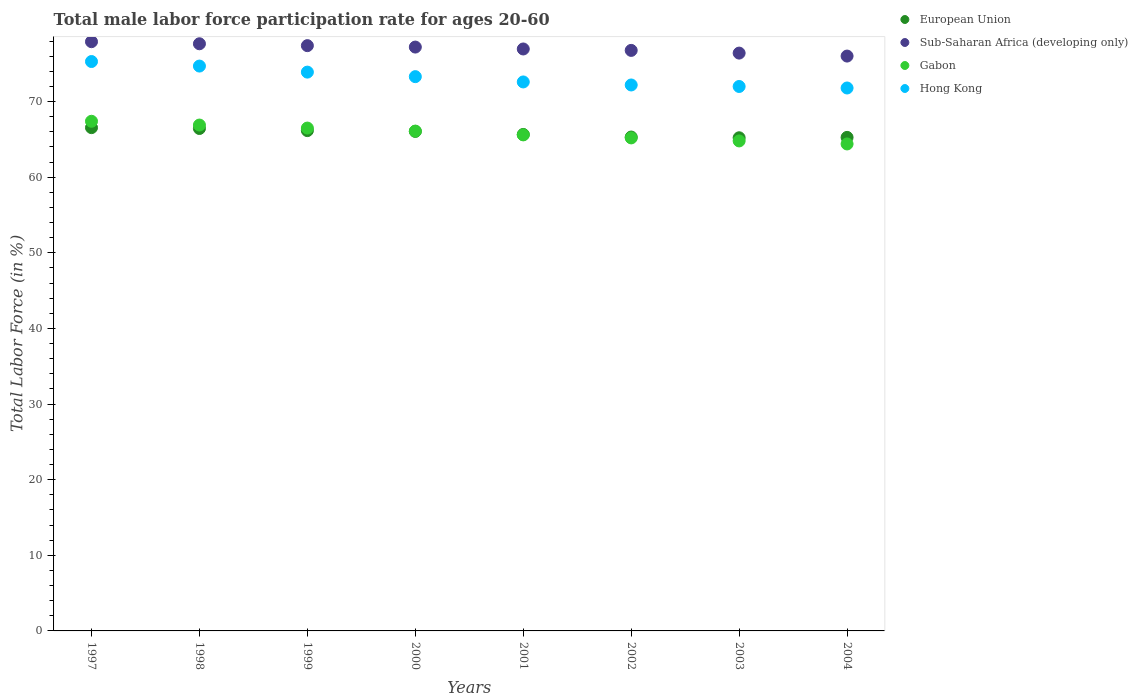How many different coloured dotlines are there?
Make the answer very short. 4. Is the number of dotlines equal to the number of legend labels?
Your answer should be compact. Yes. What is the male labor force participation rate in Gabon in 1998?
Your response must be concise. 66.9. Across all years, what is the maximum male labor force participation rate in Sub-Saharan Africa (developing only)?
Give a very brief answer. 77.92. Across all years, what is the minimum male labor force participation rate in European Union?
Offer a terse response. 65.22. In which year was the male labor force participation rate in European Union maximum?
Ensure brevity in your answer.  1997. What is the total male labor force participation rate in Hong Kong in the graph?
Your answer should be very brief. 585.8. What is the difference between the male labor force participation rate in European Union in 1997 and that in 2001?
Your answer should be compact. 0.9. What is the difference between the male labor force participation rate in European Union in 2001 and the male labor force participation rate in Gabon in 2000?
Offer a very short reply. -0.44. What is the average male labor force participation rate in European Union per year?
Offer a very short reply. 65.84. In the year 1999, what is the difference between the male labor force participation rate in Gabon and male labor force participation rate in European Union?
Keep it short and to the point. 0.34. In how many years, is the male labor force participation rate in Gabon greater than 60 %?
Give a very brief answer. 8. What is the ratio of the male labor force participation rate in European Union in 1998 to that in 1999?
Offer a very short reply. 1. Is the male labor force participation rate in Hong Kong in 2000 less than that in 2001?
Make the answer very short. No. Is the difference between the male labor force participation rate in Gabon in 1997 and 2003 greater than the difference between the male labor force participation rate in European Union in 1997 and 2003?
Give a very brief answer. Yes. What is the difference between the highest and the second highest male labor force participation rate in Sub-Saharan Africa (developing only)?
Ensure brevity in your answer.  0.28. In how many years, is the male labor force participation rate in Gabon greater than the average male labor force participation rate in Gabon taken over all years?
Offer a very short reply. 4. Is it the case that in every year, the sum of the male labor force participation rate in Sub-Saharan Africa (developing only) and male labor force participation rate in Hong Kong  is greater than the male labor force participation rate in Gabon?
Offer a very short reply. Yes. Is the male labor force participation rate in Gabon strictly less than the male labor force participation rate in Hong Kong over the years?
Make the answer very short. Yes. How many dotlines are there?
Your response must be concise. 4. Does the graph contain any zero values?
Provide a short and direct response. No. Where does the legend appear in the graph?
Ensure brevity in your answer.  Top right. What is the title of the graph?
Your answer should be compact. Total male labor force participation rate for ages 20-60. What is the label or title of the X-axis?
Your answer should be very brief. Years. What is the label or title of the Y-axis?
Your answer should be compact. Total Labor Force (in %). What is the Total Labor Force (in %) of European Union in 1997?
Provide a short and direct response. 66.56. What is the Total Labor Force (in %) in Sub-Saharan Africa (developing only) in 1997?
Your response must be concise. 77.92. What is the Total Labor Force (in %) of Gabon in 1997?
Ensure brevity in your answer.  67.4. What is the Total Labor Force (in %) in Hong Kong in 1997?
Keep it short and to the point. 75.3. What is the Total Labor Force (in %) of European Union in 1998?
Your response must be concise. 66.44. What is the Total Labor Force (in %) in Sub-Saharan Africa (developing only) in 1998?
Offer a terse response. 77.65. What is the Total Labor Force (in %) in Gabon in 1998?
Offer a very short reply. 66.9. What is the Total Labor Force (in %) of Hong Kong in 1998?
Make the answer very short. 74.7. What is the Total Labor Force (in %) of European Union in 1999?
Your answer should be compact. 66.16. What is the Total Labor Force (in %) in Sub-Saharan Africa (developing only) in 1999?
Your answer should be compact. 77.4. What is the Total Labor Force (in %) of Gabon in 1999?
Provide a short and direct response. 66.5. What is the Total Labor Force (in %) in Hong Kong in 1999?
Your response must be concise. 73.9. What is the Total Labor Force (in %) of European Union in 2000?
Your answer should be compact. 66.06. What is the Total Labor Force (in %) in Sub-Saharan Africa (developing only) in 2000?
Your answer should be compact. 77.21. What is the Total Labor Force (in %) of Gabon in 2000?
Provide a short and direct response. 66.1. What is the Total Labor Force (in %) in Hong Kong in 2000?
Provide a short and direct response. 73.3. What is the Total Labor Force (in %) of European Union in 2001?
Make the answer very short. 65.66. What is the Total Labor Force (in %) in Sub-Saharan Africa (developing only) in 2001?
Your answer should be compact. 76.96. What is the Total Labor Force (in %) in Gabon in 2001?
Provide a short and direct response. 65.6. What is the Total Labor Force (in %) in Hong Kong in 2001?
Provide a short and direct response. 72.6. What is the Total Labor Force (in %) in European Union in 2002?
Ensure brevity in your answer.  65.31. What is the Total Labor Force (in %) of Sub-Saharan Africa (developing only) in 2002?
Provide a short and direct response. 76.77. What is the Total Labor Force (in %) of Gabon in 2002?
Keep it short and to the point. 65.2. What is the Total Labor Force (in %) of Hong Kong in 2002?
Your answer should be very brief. 72.2. What is the Total Labor Force (in %) of European Union in 2003?
Your response must be concise. 65.22. What is the Total Labor Force (in %) in Sub-Saharan Africa (developing only) in 2003?
Offer a terse response. 76.42. What is the Total Labor Force (in %) of Gabon in 2003?
Keep it short and to the point. 64.8. What is the Total Labor Force (in %) of Hong Kong in 2003?
Your answer should be compact. 72. What is the Total Labor Force (in %) of European Union in 2004?
Your answer should be very brief. 65.27. What is the Total Labor Force (in %) of Sub-Saharan Africa (developing only) in 2004?
Provide a short and direct response. 76.02. What is the Total Labor Force (in %) in Gabon in 2004?
Your answer should be very brief. 64.4. What is the Total Labor Force (in %) of Hong Kong in 2004?
Your answer should be compact. 71.8. Across all years, what is the maximum Total Labor Force (in %) in European Union?
Offer a very short reply. 66.56. Across all years, what is the maximum Total Labor Force (in %) in Sub-Saharan Africa (developing only)?
Your answer should be very brief. 77.92. Across all years, what is the maximum Total Labor Force (in %) in Gabon?
Provide a succinct answer. 67.4. Across all years, what is the maximum Total Labor Force (in %) in Hong Kong?
Your answer should be compact. 75.3. Across all years, what is the minimum Total Labor Force (in %) in European Union?
Provide a short and direct response. 65.22. Across all years, what is the minimum Total Labor Force (in %) in Sub-Saharan Africa (developing only)?
Your response must be concise. 76.02. Across all years, what is the minimum Total Labor Force (in %) of Gabon?
Make the answer very short. 64.4. Across all years, what is the minimum Total Labor Force (in %) of Hong Kong?
Provide a short and direct response. 71.8. What is the total Total Labor Force (in %) of European Union in the graph?
Provide a succinct answer. 526.68. What is the total Total Labor Force (in %) in Sub-Saharan Africa (developing only) in the graph?
Provide a short and direct response. 616.36. What is the total Total Labor Force (in %) of Gabon in the graph?
Your answer should be very brief. 526.9. What is the total Total Labor Force (in %) of Hong Kong in the graph?
Your answer should be compact. 585.8. What is the difference between the Total Labor Force (in %) of European Union in 1997 and that in 1998?
Give a very brief answer. 0.11. What is the difference between the Total Labor Force (in %) in Sub-Saharan Africa (developing only) in 1997 and that in 1998?
Your answer should be very brief. 0.28. What is the difference between the Total Labor Force (in %) in Gabon in 1997 and that in 1998?
Ensure brevity in your answer.  0.5. What is the difference between the Total Labor Force (in %) of Hong Kong in 1997 and that in 1998?
Make the answer very short. 0.6. What is the difference between the Total Labor Force (in %) of European Union in 1997 and that in 1999?
Make the answer very short. 0.39. What is the difference between the Total Labor Force (in %) in Sub-Saharan Africa (developing only) in 1997 and that in 1999?
Provide a short and direct response. 0.52. What is the difference between the Total Labor Force (in %) in European Union in 1997 and that in 2000?
Make the answer very short. 0.5. What is the difference between the Total Labor Force (in %) of Sub-Saharan Africa (developing only) in 1997 and that in 2000?
Provide a short and direct response. 0.71. What is the difference between the Total Labor Force (in %) of European Union in 1997 and that in 2001?
Provide a succinct answer. 0.9. What is the difference between the Total Labor Force (in %) in Sub-Saharan Africa (developing only) in 1997 and that in 2001?
Provide a short and direct response. 0.96. What is the difference between the Total Labor Force (in %) in Gabon in 1997 and that in 2001?
Offer a very short reply. 1.8. What is the difference between the Total Labor Force (in %) in Hong Kong in 1997 and that in 2001?
Make the answer very short. 2.7. What is the difference between the Total Labor Force (in %) in European Union in 1997 and that in 2002?
Ensure brevity in your answer.  1.24. What is the difference between the Total Labor Force (in %) of Sub-Saharan Africa (developing only) in 1997 and that in 2002?
Your response must be concise. 1.15. What is the difference between the Total Labor Force (in %) of Gabon in 1997 and that in 2002?
Offer a very short reply. 2.2. What is the difference between the Total Labor Force (in %) of Hong Kong in 1997 and that in 2002?
Make the answer very short. 3.1. What is the difference between the Total Labor Force (in %) in European Union in 1997 and that in 2003?
Provide a succinct answer. 1.34. What is the difference between the Total Labor Force (in %) in Sub-Saharan Africa (developing only) in 1997 and that in 2003?
Give a very brief answer. 1.51. What is the difference between the Total Labor Force (in %) in Hong Kong in 1997 and that in 2003?
Offer a very short reply. 3.3. What is the difference between the Total Labor Force (in %) of European Union in 1997 and that in 2004?
Your response must be concise. 1.29. What is the difference between the Total Labor Force (in %) in Sub-Saharan Africa (developing only) in 1997 and that in 2004?
Your answer should be very brief. 1.9. What is the difference between the Total Labor Force (in %) of European Union in 1998 and that in 1999?
Your answer should be compact. 0.28. What is the difference between the Total Labor Force (in %) of Sub-Saharan Africa (developing only) in 1998 and that in 1999?
Keep it short and to the point. 0.25. What is the difference between the Total Labor Force (in %) in European Union in 1998 and that in 2000?
Your answer should be compact. 0.38. What is the difference between the Total Labor Force (in %) of Sub-Saharan Africa (developing only) in 1998 and that in 2000?
Offer a very short reply. 0.44. What is the difference between the Total Labor Force (in %) in Gabon in 1998 and that in 2000?
Your response must be concise. 0.8. What is the difference between the Total Labor Force (in %) in Hong Kong in 1998 and that in 2000?
Ensure brevity in your answer.  1.4. What is the difference between the Total Labor Force (in %) of European Union in 1998 and that in 2001?
Ensure brevity in your answer.  0.79. What is the difference between the Total Labor Force (in %) in Sub-Saharan Africa (developing only) in 1998 and that in 2001?
Your answer should be compact. 0.69. What is the difference between the Total Labor Force (in %) of Gabon in 1998 and that in 2001?
Provide a short and direct response. 1.3. What is the difference between the Total Labor Force (in %) in European Union in 1998 and that in 2002?
Your response must be concise. 1.13. What is the difference between the Total Labor Force (in %) in Sub-Saharan Africa (developing only) in 1998 and that in 2002?
Offer a very short reply. 0.88. What is the difference between the Total Labor Force (in %) in Gabon in 1998 and that in 2002?
Your answer should be compact. 1.7. What is the difference between the Total Labor Force (in %) of Hong Kong in 1998 and that in 2002?
Offer a terse response. 2.5. What is the difference between the Total Labor Force (in %) of European Union in 1998 and that in 2003?
Offer a very short reply. 1.23. What is the difference between the Total Labor Force (in %) in Sub-Saharan Africa (developing only) in 1998 and that in 2003?
Your answer should be compact. 1.23. What is the difference between the Total Labor Force (in %) of Gabon in 1998 and that in 2003?
Your answer should be compact. 2.1. What is the difference between the Total Labor Force (in %) of Hong Kong in 1998 and that in 2003?
Keep it short and to the point. 2.7. What is the difference between the Total Labor Force (in %) of European Union in 1998 and that in 2004?
Your response must be concise. 1.18. What is the difference between the Total Labor Force (in %) of Sub-Saharan Africa (developing only) in 1998 and that in 2004?
Your response must be concise. 1.63. What is the difference between the Total Labor Force (in %) of Gabon in 1998 and that in 2004?
Your answer should be compact. 2.5. What is the difference between the Total Labor Force (in %) of Hong Kong in 1998 and that in 2004?
Keep it short and to the point. 2.9. What is the difference between the Total Labor Force (in %) of European Union in 1999 and that in 2000?
Offer a very short reply. 0.1. What is the difference between the Total Labor Force (in %) of Sub-Saharan Africa (developing only) in 1999 and that in 2000?
Make the answer very short. 0.19. What is the difference between the Total Labor Force (in %) of Gabon in 1999 and that in 2000?
Your response must be concise. 0.4. What is the difference between the Total Labor Force (in %) in European Union in 1999 and that in 2001?
Give a very brief answer. 0.51. What is the difference between the Total Labor Force (in %) in Sub-Saharan Africa (developing only) in 1999 and that in 2001?
Give a very brief answer. 0.44. What is the difference between the Total Labor Force (in %) in European Union in 1999 and that in 2002?
Make the answer very short. 0.85. What is the difference between the Total Labor Force (in %) in Sub-Saharan Africa (developing only) in 1999 and that in 2002?
Give a very brief answer. 0.63. What is the difference between the Total Labor Force (in %) in Gabon in 1999 and that in 2002?
Your answer should be compact. 1.3. What is the difference between the Total Labor Force (in %) of Hong Kong in 1999 and that in 2002?
Provide a short and direct response. 1.7. What is the difference between the Total Labor Force (in %) of European Union in 1999 and that in 2003?
Ensure brevity in your answer.  0.95. What is the difference between the Total Labor Force (in %) of Gabon in 1999 and that in 2003?
Offer a terse response. 1.7. What is the difference between the Total Labor Force (in %) in European Union in 1999 and that in 2004?
Offer a terse response. 0.9. What is the difference between the Total Labor Force (in %) in Sub-Saharan Africa (developing only) in 1999 and that in 2004?
Your answer should be compact. 1.38. What is the difference between the Total Labor Force (in %) of Hong Kong in 1999 and that in 2004?
Your response must be concise. 2.1. What is the difference between the Total Labor Force (in %) in European Union in 2000 and that in 2001?
Your response must be concise. 0.41. What is the difference between the Total Labor Force (in %) in Sub-Saharan Africa (developing only) in 2000 and that in 2001?
Your response must be concise. 0.25. What is the difference between the Total Labor Force (in %) of Gabon in 2000 and that in 2001?
Provide a succinct answer. 0.5. What is the difference between the Total Labor Force (in %) of Hong Kong in 2000 and that in 2001?
Ensure brevity in your answer.  0.7. What is the difference between the Total Labor Force (in %) of European Union in 2000 and that in 2002?
Your answer should be very brief. 0.75. What is the difference between the Total Labor Force (in %) in Sub-Saharan Africa (developing only) in 2000 and that in 2002?
Offer a terse response. 0.44. What is the difference between the Total Labor Force (in %) in Gabon in 2000 and that in 2002?
Your answer should be very brief. 0.9. What is the difference between the Total Labor Force (in %) of European Union in 2000 and that in 2003?
Make the answer very short. 0.84. What is the difference between the Total Labor Force (in %) of Sub-Saharan Africa (developing only) in 2000 and that in 2003?
Provide a short and direct response. 0.8. What is the difference between the Total Labor Force (in %) in Hong Kong in 2000 and that in 2003?
Keep it short and to the point. 1.3. What is the difference between the Total Labor Force (in %) in European Union in 2000 and that in 2004?
Ensure brevity in your answer.  0.79. What is the difference between the Total Labor Force (in %) of Sub-Saharan Africa (developing only) in 2000 and that in 2004?
Ensure brevity in your answer.  1.19. What is the difference between the Total Labor Force (in %) in Gabon in 2000 and that in 2004?
Your answer should be very brief. 1.7. What is the difference between the Total Labor Force (in %) of Hong Kong in 2000 and that in 2004?
Make the answer very short. 1.5. What is the difference between the Total Labor Force (in %) in European Union in 2001 and that in 2002?
Provide a succinct answer. 0.34. What is the difference between the Total Labor Force (in %) of Sub-Saharan Africa (developing only) in 2001 and that in 2002?
Ensure brevity in your answer.  0.19. What is the difference between the Total Labor Force (in %) of Gabon in 2001 and that in 2002?
Make the answer very short. 0.4. What is the difference between the Total Labor Force (in %) of Hong Kong in 2001 and that in 2002?
Provide a short and direct response. 0.4. What is the difference between the Total Labor Force (in %) of European Union in 2001 and that in 2003?
Your answer should be compact. 0.44. What is the difference between the Total Labor Force (in %) in Sub-Saharan Africa (developing only) in 2001 and that in 2003?
Ensure brevity in your answer.  0.54. What is the difference between the Total Labor Force (in %) of Gabon in 2001 and that in 2003?
Offer a terse response. 0.8. What is the difference between the Total Labor Force (in %) of Hong Kong in 2001 and that in 2003?
Provide a succinct answer. 0.6. What is the difference between the Total Labor Force (in %) of European Union in 2001 and that in 2004?
Your answer should be very brief. 0.39. What is the difference between the Total Labor Force (in %) of Gabon in 2001 and that in 2004?
Provide a succinct answer. 1.2. What is the difference between the Total Labor Force (in %) in Hong Kong in 2001 and that in 2004?
Make the answer very short. 0.8. What is the difference between the Total Labor Force (in %) in European Union in 2002 and that in 2003?
Your response must be concise. 0.1. What is the difference between the Total Labor Force (in %) in Sub-Saharan Africa (developing only) in 2002 and that in 2003?
Keep it short and to the point. 0.36. What is the difference between the Total Labor Force (in %) in Hong Kong in 2002 and that in 2003?
Your answer should be compact. 0.2. What is the difference between the Total Labor Force (in %) of European Union in 2002 and that in 2004?
Provide a succinct answer. 0.05. What is the difference between the Total Labor Force (in %) in Sub-Saharan Africa (developing only) in 2002 and that in 2004?
Make the answer very short. 0.75. What is the difference between the Total Labor Force (in %) in Gabon in 2002 and that in 2004?
Provide a succinct answer. 0.8. What is the difference between the Total Labor Force (in %) of Hong Kong in 2002 and that in 2004?
Offer a very short reply. 0.4. What is the difference between the Total Labor Force (in %) of European Union in 2003 and that in 2004?
Your answer should be compact. -0.05. What is the difference between the Total Labor Force (in %) of Sub-Saharan Africa (developing only) in 2003 and that in 2004?
Give a very brief answer. 0.39. What is the difference between the Total Labor Force (in %) of Gabon in 2003 and that in 2004?
Your answer should be compact. 0.4. What is the difference between the Total Labor Force (in %) in European Union in 1997 and the Total Labor Force (in %) in Sub-Saharan Africa (developing only) in 1998?
Make the answer very short. -11.09. What is the difference between the Total Labor Force (in %) of European Union in 1997 and the Total Labor Force (in %) of Gabon in 1998?
Ensure brevity in your answer.  -0.34. What is the difference between the Total Labor Force (in %) of European Union in 1997 and the Total Labor Force (in %) of Hong Kong in 1998?
Offer a very short reply. -8.14. What is the difference between the Total Labor Force (in %) in Sub-Saharan Africa (developing only) in 1997 and the Total Labor Force (in %) in Gabon in 1998?
Your answer should be very brief. 11.02. What is the difference between the Total Labor Force (in %) in Sub-Saharan Africa (developing only) in 1997 and the Total Labor Force (in %) in Hong Kong in 1998?
Offer a terse response. 3.22. What is the difference between the Total Labor Force (in %) of European Union in 1997 and the Total Labor Force (in %) of Sub-Saharan Africa (developing only) in 1999?
Your answer should be very brief. -10.84. What is the difference between the Total Labor Force (in %) in European Union in 1997 and the Total Labor Force (in %) in Gabon in 1999?
Provide a short and direct response. 0.06. What is the difference between the Total Labor Force (in %) in European Union in 1997 and the Total Labor Force (in %) in Hong Kong in 1999?
Give a very brief answer. -7.34. What is the difference between the Total Labor Force (in %) of Sub-Saharan Africa (developing only) in 1997 and the Total Labor Force (in %) of Gabon in 1999?
Ensure brevity in your answer.  11.42. What is the difference between the Total Labor Force (in %) of Sub-Saharan Africa (developing only) in 1997 and the Total Labor Force (in %) of Hong Kong in 1999?
Provide a short and direct response. 4.02. What is the difference between the Total Labor Force (in %) in European Union in 1997 and the Total Labor Force (in %) in Sub-Saharan Africa (developing only) in 2000?
Provide a short and direct response. -10.65. What is the difference between the Total Labor Force (in %) of European Union in 1997 and the Total Labor Force (in %) of Gabon in 2000?
Your answer should be compact. 0.46. What is the difference between the Total Labor Force (in %) of European Union in 1997 and the Total Labor Force (in %) of Hong Kong in 2000?
Make the answer very short. -6.74. What is the difference between the Total Labor Force (in %) in Sub-Saharan Africa (developing only) in 1997 and the Total Labor Force (in %) in Gabon in 2000?
Your answer should be very brief. 11.82. What is the difference between the Total Labor Force (in %) in Sub-Saharan Africa (developing only) in 1997 and the Total Labor Force (in %) in Hong Kong in 2000?
Provide a short and direct response. 4.62. What is the difference between the Total Labor Force (in %) in European Union in 1997 and the Total Labor Force (in %) in Sub-Saharan Africa (developing only) in 2001?
Your answer should be very brief. -10.4. What is the difference between the Total Labor Force (in %) in European Union in 1997 and the Total Labor Force (in %) in Gabon in 2001?
Keep it short and to the point. 0.96. What is the difference between the Total Labor Force (in %) in European Union in 1997 and the Total Labor Force (in %) in Hong Kong in 2001?
Your answer should be compact. -6.04. What is the difference between the Total Labor Force (in %) of Sub-Saharan Africa (developing only) in 1997 and the Total Labor Force (in %) of Gabon in 2001?
Offer a terse response. 12.32. What is the difference between the Total Labor Force (in %) in Sub-Saharan Africa (developing only) in 1997 and the Total Labor Force (in %) in Hong Kong in 2001?
Provide a succinct answer. 5.32. What is the difference between the Total Labor Force (in %) of Gabon in 1997 and the Total Labor Force (in %) of Hong Kong in 2001?
Keep it short and to the point. -5.2. What is the difference between the Total Labor Force (in %) in European Union in 1997 and the Total Labor Force (in %) in Sub-Saharan Africa (developing only) in 2002?
Offer a very short reply. -10.21. What is the difference between the Total Labor Force (in %) of European Union in 1997 and the Total Labor Force (in %) of Gabon in 2002?
Provide a short and direct response. 1.36. What is the difference between the Total Labor Force (in %) in European Union in 1997 and the Total Labor Force (in %) in Hong Kong in 2002?
Your answer should be very brief. -5.64. What is the difference between the Total Labor Force (in %) of Sub-Saharan Africa (developing only) in 1997 and the Total Labor Force (in %) of Gabon in 2002?
Provide a succinct answer. 12.72. What is the difference between the Total Labor Force (in %) in Sub-Saharan Africa (developing only) in 1997 and the Total Labor Force (in %) in Hong Kong in 2002?
Make the answer very short. 5.72. What is the difference between the Total Labor Force (in %) in European Union in 1997 and the Total Labor Force (in %) in Sub-Saharan Africa (developing only) in 2003?
Your answer should be compact. -9.86. What is the difference between the Total Labor Force (in %) in European Union in 1997 and the Total Labor Force (in %) in Gabon in 2003?
Give a very brief answer. 1.76. What is the difference between the Total Labor Force (in %) of European Union in 1997 and the Total Labor Force (in %) of Hong Kong in 2003?
Your response must be concise. -5.44. What is the difference between the Total Labor Force (in %) in Sub-Saharan Africa (developing only) in 1997 and the Total Labor Force (in %) in Gabon in 2003?
Ensure brevity in your answer.  13.12. What is the difference between the Total Labor Force (in %) of Sub-Saharan Africa (developing only) in 1997 and the Total Labor Force (in %) of Hong Kong in 2003?
Keep it short and to the point. 5.92. What is the difference between the Total Labor Force (in %) of European Union in 1997 and the Total Labor Force (in %) of Sub-Saharan Africa (developing only) in 2004?
Offer a terse response. -9.46. What is the difference between the Total Labor Force (in %) in European Union in 1997 and the Total Labor Force (in %) in Gabon in 2004?
Make the answer very short. 2.16. What is the difference between the Total Labor Force (in %) of European Union in 1997 and the Total Labor Force (in %) of Hong Kong in 2004?
Your answer should be very brief. -5.24. What is the difference between the Total Labor Force (in %) in Sub-Saharan Africa (developing only) in 1997 and the Total Labor Force (in %) in Gabon in 2004?
Offer a very short reply. 13.52. What is the difference between the Total Labor Force (in %) in Sub-Saharan Africa (developing only) in 1997 and the Total Labor Force (in %) in Hong Kong in 2004?
Ensure brevity in your answer.  6.12. What is the difference between the Total Labor Force (in %) in Gabon in 1997 and the Total Labor Force (in %) in Hong Kong in 2004?
Your response must be concise. -4.4. What is the difference between the Total Labor Force (in %) of European Union in 1998 and the Total Labor Force (in %) of Sub-Saharan Africa (developing only) in 1999?
Provide a succinct answer. -10.96. What is the difference between the Total Labor Force (in %) of European Union in 1998 and the Total Labor Force (in %) of Gabon in 1999?
Keep it short and to the point. -0.06. What is the difference between the Total Labor Force (in %) in European Union in 1998 and the Total Labor Force (in %) in Hong Kong in 1999?
Ensure brevity in your answer.  -7.46. What is the difference between the Total Labor Force (in %) in Sub-Saharan Africa (developing only) in 1998 and the Total Labor Force (in %) in Gabon in 1999?
Keep it short and to the point. 11.15. What is the difference between the Total Labor Force (in %) in Sub-Saharan Africa (developing only) in 1998 and the Total Labor Force (in %) in Hong Kong in 1999?
Offer a very short reply. 3.75. What is the difference between the Total Labor Force (in %) in Gabon in 1998 and the Total Labor Force (in %) in Hong Kong in 1999?
Your answer should be compact. -7. What is the difference between the Total Labor Force (in %) in European Union in 1998 and the Total Labor Force (in %) in Sub-Saharan Africa (developing only) in 2000?
Provide a short and direct response. -10.77. What is the difference between the Total Labor Force (in %) of European Union in 1998 and the Total Labor Force (in %) of Gabon in 2000?
Your answer should be very brief. 0.34. What is the difference between the Total Labor Force (in %) in European Union in 1998 and the Total Labor Force (in %) in Hong Kong in 2000?
Provide a short and direct response. -6.86. What is the difference between the Total Labor Force (in %) in Sub-Saharan Africa (developing only) in 1998 and the Total Labor Force (in %) in Gabon in 2000?
Offer a very short reply. 11.55. What is the difference between the Total Labor Force (in %) of Sub-Saharan Africa (developing only) in 1998 and the Total Labor Force (in %) of Hong Kong in 2000?
Offer a terse response. 4.35. What is the difference between the Total Labor Force (in %) in European Union in 1998 and the Total Labor Force (in %) in Sub-Saharan Africa (developing only) in 2001?
Provide a short and direct response. -10.52. What is the difference between the Total Labor Force (in %) of European Union in 1998 and the Total Labor Force (in %) of Gabon in 2001?
Ensure brevity in your answer.  0.84. What is the difference between the Total Labor Force (in %) in European Union in 1998 and the Total Labor Force (in %) in Hong Kong in 2001?
Offer a terse response. -6.16. What is the difference between the Total Labor Force (in %) in Sub-Saharan Africa (developing only) in 1998 and the Total Labor Force (in %) in Gabon in 2001?
Your answer should be compact. 12.05. What is the difference between the Total Labor Force (in %) of Sub-Saharan Africa (developing only) in 1998 and the Total Labor Force (in %) of Hong Kong in 2001?
Your answer should be compact. 5.05. What is the difference between the Total Labor Force (in %) in Gabon in 1998 and the Total Labor Force (in %) in Hong Kong in 2001?
Give a very brief answer. -5.7. What is the difference between the Total Labor Force (in %) of European Union in 1998 and the Total Labor Force (in %) of Sub-Saharan Africa (developing only) in 2002?
Offer a very short reply. -10.33. What is the difference between the Total Labor Force (in %) in European Union in 1998 and the Total Labor Force (in %) in Gabon in 2002?
Make the answer very short. 1.24. What is the difference between the Total Labor Force (in %) of European Union in 1998 and the Total Labor Force (in %) of Hong Kong in 2002?
Offer a terse response. -5.76. What is the difference between the Total Labor Force (in %) of Sub-Saharan Africa (developing only) in 1998 and the Total Labor Force (in %) of Gabon in 2002?
Ensure brevity in your answer.  12.45. What is the difference between the Total Labor Force (in %) in Sub-Saharan Africa (developing only) in 1998 and the Total Labor Force (in %) in Hong Kong in 2002?
Offer a very short reply. 5.45. What is the difference between the Total Labor Force (in %) in Gabon in 1998 and the Total Labor Force (in %) in Hong Kong in 2002?
Offer a terse response. -5.3. What is the difference between the Total Labor Force (in %) of European Union in 1998 and the Total Labor Force (in %) of Sub-Saharan Africa (developing only) in 2003?
Make the answer very short. -9.97. What is the difference between the Total Labor Force (in %) in European Union in 1998 and the Total Labor Force (in %) in Gabon in 2003?
Offer a terse response. 1.64. What is the difference between the Total Labor Force (in %) in European Union in 1998 and the Total Labor Force (in %) in Hong Kong in 2003?
Ensure brevity in your answer.  -5.56. What is the difference between the Total Labor Force (in %) of Sub-Saharan Africa (developing only) in 1998 and the Total Labor Force (in %) of Gabon in 2003?
Make the answer very short. 12.85. What is the difference between the Total Labor Force (in %) in Sub-Saharan Africa (developing only) in 1998 and the Total Labor Force (in %) in Hong Kong in 2003?
Offer a terse response. 5.65. What is the difference between the Total Labor Force (in %) in Gabon in 1998 and the Total Labor Force (in %) in Hong Kong in 2003?
Give a very brief answer. -5.1. What is the difference between the Total Labor Force (in %) in European Union in 1998 and the Total Labor Force (in %) in Sub-Saharan Africa (developing only) in 2004?
Offer a terse response. -9.58. What is the difference between the Total Labor Force (in %) in European Union in 1998 and the Total Labor Force (in %) in Gabon in 2004?
Provide a short and direct response. 2.04. What is the difference between the Total Labor Force (in %) in European Union in 1998 and the Total Labor Force (in %) in Hong Kong in 2004?
Your response must be concise. -5.36. What is the difference between the Total Labor Force (in %) in Sub-Saharan Africa (developing only) in 1998 and the Total Labor Force (in %) in Gabon in 2004?
Give a very brief answer. 13.25. What is the difference between the Total Labor Force (in %) in Sub-Saharan Africa (developing only) in 1998 and the Total Labor Force (in %) in Hong Kong in 2004?
Offer a terse response. 5.85. What is the difference between the Total Labor Force (in %) in Gabon in 1998 and the Total Labor Force (in %) in Hong Kong in 2004?
Make the answer very short. -4.9. What is the difference between the Total Labor Force (in %) of European Union in 1999 and the Total Labor Force (in %) of Sub-Saharan Africa (developing only) in 2000?
Your response must be concise. -11.05. What is the difference between the Total Labor Force (in %) in European Union in 1999 and the Total Labor Force (in %) in Gabon in 2000?
Offer a very short reply. 0.06. What is the difference between the Total Labor Force (in %) of European Union in 1999 and the Total Labor Force (in %) of Hong Kong in 2000?
Your answer should be very brief. -7.14. What is the difference between the Total Labor Force (in %) of Sub-Saharan Africa (developing only) in 1999 and the Total Labor Force (in %) of Gabon in 2000?
Your answer should be very brief. 11.3. What is the difference between the Total Labor Force (in %) in Sub-Saharan Africa (developing only) in 1999 and the Total Labor Force (in %) in Hong Kong in 2000?
Give a very brief answer. 4.1. What is the difference between the Total Labor Force (in %) of Gabon in 1999 and the Total Labor Force (in %) of Hong Kong in 2000?
Provide a short and direct response. -6.8. What is the difference between the Total Labor Force (in %) of European Union in 1999 and the Total Labor Force (in %) of Sub-Saharan Africa (developing only) in 2001?
Make the answer very short. -10.8. What is the difference between the Total Labor Force (in %) in European Union in 1999 and the Total Labor Force (in %) in Gabon in 2001?
Your answer should be very brief. 0.56. What is the difference between the Total Labor Force (in %) in European Union in 1999 and the Total Labor Force (in %) in Hong Kong in 2001?
Provide a succinct answer. -6.44. What is the difference between the Total Labor Force (in %) in Sub-Saharan Africa (developing only) in 1999 and the Total Labor Force (in %) in Gabon in 2001?
Ensure brevity in your answer.  11.8. What is the difference between the Total Labor Force (in %) of Sub-Saharan Africa (developing only) in 1999 and the Total Labor Force (in %) of Hong Kong in 2001?
Ensure brevity in your answer.  4.8. What is the difference between the Total Labor Force (in %) in Gabon in 1999 and the Total Labor Force (in %) in Hong Kong in 2001?
Your answer should be very brief. -6.1. What is the difference between the Total Labor Force (in %) of European Union in 1999 and the Total Labor Force (in %) of Sub-Saharan Africa (developing only) in 2002?
Give a very brief answer. -10.61. What is the difference between the Total Labor Force (in %) in European Union in 1999 and the Total Labor Force (in %) in Gabon in 2002?
Provide a succinct answer. 0.96. What is the difference between the Total Labor Force (in %) in European Union in 1999 and the Total Labor Force (in %) in Hong Kong in 2002?
Provide a short and direct response. -6.04. What is the difference between the Total Labor Force (in %) in Sub-Saharan Africa (developing only) in 1999 and the Total Labor Force (in %) in Gabon in 2002?
Give a very brief answer. 12.2. What is the difference between the Total Labor Force (in %) in Sub-Saharan Africa (developing only) in 1999 and the Total Labor Force (in %) in Hong Kong in 2002?
Your answer should be very brief. 5.2. What is the difference between the Total Labor Force (in %) in Gabon in 1999 and the Total Labor Force (in %) in Hong Kong in 2002?
Your response must be concise. -5.7. What is the difference between the Total Labor Force (in %) of European Union in 1999 and the Total Labor Force (in %) of Sub-Saharan Africa (developing only) in 2003?
Your answer should be very brief. -10.25. What is the difference between the Total Labor Force (in %) of European Union in 1999 and the Total Labor Force (in %) of Gabon in 2003?
Provide a short and direct response. 1.36. What is the difference between the Total Labor Force (in %) in European Union in 1999 and the Total Labor Force (in %) in Hong Kong in 2003?
Provide a succinct answer. -5.84. What is the difference between the Total Labor Force (in %) in Sub-Saharan Africa (developing only) in 1999 and the Total Labor Force (in %) in Gabon in 2003?
Provide a succinct answer. 12.6. What is the difference between the Total Labor Force (in %) of Sub-Saharan Africa (developing only) in 1999 and the Total Labor Force (in %) of Hong Kong in 2003?
Ensure brevity in your answer.  5.4. What is the difference between the Total Labor Force (in %) in Gabon in 1999 and the Total Labor Force (in %) in Hong Kong in 2003?
Your response must be concise. -5.5. What is the difference between the Total Labor Force (in %) of European Union in 1999 and the Total Labor Force (in %) of Sub-Saharan Africa (developing only) in 2004?
Your response must be concise. -9.86. What is the difference between the Total Labor Force (in %) in European Union in 1999 and the Total Labor Force (in %) in Gabon in 2004?
Your answer should be very brief. 1.76. What is the difference between the Total Labor Force (in %) in European Union in 1999 and the Total Labor Force (in %) in Hong Kong in 2004?
Make the answer very short. -5.64. What is the difference between the Total Labor Force (in %) in Sub-Saharan Africa (developing only) in 1999 and the Total Labor Force (in %) in Gabon in 2004?
Provide a succinct answer. 13. What is the difference between the Total Labor Force (in %) in Sub-Saharan Africa (developing only) in 1999 and the Total Labor Force (in %) in Hong Kong in 2004?
Offer a terse response. 5.6. What is the difference between the Total Labor Force (in %) in Gabon in 1999 and the Total Labor Force (in %) in Hong Kong in 2004?
Provide a succinct answer. -5.3. What is the difference between the Total Labor Force (in %) in European Union in 2000 and the Total Labor Force (in %) in Sub-Saharan Africa (developing only) in 2001?
Your answer should be very brief. -10.9. What is the difference between the Total Labor Force (in %) in European Union in 2000 and the Total Labor Force (in %) in Gabon in 2001?
Your answer should be very brief. 0.46. What is the difference between the Total Labor Force (in %) of European Union in 2000 and the Total Labor Force (in %) of Hong Kong in 2001?
Give a very brief answer. -6.54. What is the difference between the Total Labor Force (in %) in Sub-Saharan Africa (developing only) in 2000 and the Total Labor Force (in %) in Gabon in 2001?
Your answer should be compact. 11.61. What is the difference between the Total Labor Force (in %) in Sub-Saharan Africa (developing only) in 2000 and the Total Labor Force (in %) in Hong Kong in 2001?
Provide a short and direct response. 4.61. What is the difference between the Total Labor Force (in %) in European Union in 2000 and the Total Labor Force (in %) in Sub-Saharan Africa (developing only) in 2002?
Offer a terse response. -10.71. What is the difference between the Total Labor Force (in %) in European Union in 2000 and the Total Labor Force (in %) in Gabon in 2002?
Give a very brief answer. 0.86. What is the difference between the Total Labor Force (in %) in European Union in 2000 and the Total Labor Force (in %) in Hong Kong in 2002?
Give a very brief answer. -6.14. What is the difference between the Total Labor Force (in %) in Sub-Saharan Africa (developing only) in 2000 and the Total Labor Force (in %) in Gabon in 2002?
Your response must be concise. 12.01. What is the difference between the Total Labor Force (in %) in Sub-Saharan Africa (developing only) in 2000 and the Total Labor Force (in %) in Hong Kong in 2002?
Make the answer very short. 5.01. What is the difference between the Total Labor Force (in %) of European Union in 2000 and the Total Labor Force (in %) of Sub-Saharan Africa (developing only) in 2003?
Offer a very short reply. -10.35. What is the difference between the Total Labor Force (in %) of European Union in 2000 and the Total Labor Force (in %) of Gabon in 2003?
Make the answer very short. 1.26. What is the difference between the Total Labor Force (in %) in European Union in 2000 and the Total Labor Force (in %) in Hong Kong in 2003?
Your response must be concise. -5.94. What is the difference between the Total Labor Force (in %) of Sub-Saharan Africa (developing only) in 2000 and the Total Labor Force (in %) of Gabon in 2003?
Give a very brief answer. 12.41. What is the difference between the Total Labor Force (in %) of Sub-Saharan Africa (developing only) in 2000 and the Total Labor Force (in %) of Hong Kong in 2003?
Your answer should be very brief. 5.21. What is the difference between the Total Labor Force (in %) in European Union in 2000 and the Total Labor Force (in %) in Sub-Saharan Africa (developing only) in 2004?
Provide a succinct answer. -9.96. What is the difference between the Total Labor Force (in %) of European Union in 2000 and the Total Labor Force (in %) of Gabon in 2004?
Make the answer very short. 1.66. What is the difference between the Total Labor Force (in %) in European Union in 2000 and the Total Labor Force (in %) in Hong Kong in 2004?
Make the answer very short. -5.74. What is the difference between the Total Labor Force (in %) in Sub-Saharan Africa (developing only) in 2000 and the Total Labor Force (in %) in Gabon in 2004?
Your answer should be very brief. 12.81. What is the difference between the Total Labor Force (in %) in Sub-Saharan Africa (developing only) in 2000 and the Total Labor Force (in %) in Hong Kong in 2004?
Ensure brevity in your answer.  5.41. What is the difference between the Total Labor Force (in %) in European Union in 2001 and the Total Labor Force (in %) in Sub-Saharan Africa (developing only) in 2002?
Provide a succinct answer. -11.12. What is the difference between the Total Labor Force (in %) in European Union in 2001 and the Total Labor Force (in %) in Gabon in 2002?
Offer a very short reply. 0.46. What is the difference between the Total Labor Force (in %) of European Union in 2001 and the Total Labor Force (in %) of Hong Kong in 2002?
Offer a very short reply. -6.54. What is the difference between the Total Labor Force (in %) of Sub-Saharan Africa (developing only) in 2001 and the Total Labor Force (in %) of Gabon in 2002?
Keep it short and to the point. 11.76. What is the difference between the Total Labor Force (in %) of Sub-Saharan Africa (developing only) in 2001 and the Total Labor Force (in %) of Hong Kong in 2002?
Give a very brief answer. 4.76. What is the difference between the Total Labor Force (in %) in European Union in 2001 and the Total Labor Force (in %) in Sub-Saharan Africa (developing only) in 2003?
Make the answer very short. -10.76. What is the difference between the Total Labor Force (in %) in European Union in 2001 and the Total Labor Force (in %) in Gabon in 2003?
Your answer should be compact. 0.86. What is the difference between the Total Labor Force (in %) of European Union in 2001 and the Total Labor Force (in %) of Hong Kong in 2003?
Offer a terse response. -6.34. What is the difference between the Total Labor Force (in %) of Sub-Saharan Africa (developing only) in 2001 and the Total Labor Force (in %) of Gabon in 2003?
Give a very brief answer. 12.16. What is the difference between the Total Labor Force (in %) in Sub-Saharan Africa (developing only) in 2001 and the Total Labor Force (in %) in Hong Kong in 2003?
Your answer should be very brief. 4.96. What is the difference between the Total Labor Force (in %) of Gabon in 2001 and the Total Labor Force (in %) of Hong Kong in 2003?
Offer a very short reply. -6.4. What is the difference between the Total Labor Force (in %) of European Union in 2001 and the Total Labor Force (in %) of Sub-Saharan Africa (developing only) in 2004?
Offer a very short reply. -10.37. What is the difference between the Total Labor Force (in %) of European Union in 2001 and the Total Labor Force (in %) of Gabon in 2004?
Provide a succinct answer. 1.26. What is the difference between the Total Labor Force (in %) in European Union in 2001 and the Total Labor Force (in %) in Hong Kong in 2004?
Give a very brief answer. -6.14. What is the difference between the Total Labor Force (in %) in Sub-Saharan Africa (developing only) in 2001 and the Total Labor Force (in %) in Gabon in 2004?
Your response must be concise. 12.56. What is the difference between the Total Labor Force (in %) of Sub-Saharan Africa (developing only) in 2001 and the Total Labor Force (in %) of Hong Kong in 2004?
Ensure brevity in your answer.  5.16. What is the difference between the Total Labor Force (in %) of Gabon in 2001 and the Total Labor Force (in %) of Hong Kong in 2004?
Ensure brevity in your answer.  -6.2. What is the difference between the Total Labor Force (in %) of European Union in 2002 and the Total Labor Force (in %) of Sub-Saharan Africa (developing only) in 2003?
Keep it short and to the point. -11.1. What is the difference between the Total Labor Force (in %) of European Union in 2002 and the Total Labor Force (in %) of Gabon in 2003?
Provide a succinct answer. 0.51. What is the difference between the Total Labor Force (in %) of European Union in 2002 and the Total Labor Force (in %) of Hong Kong in 2003?
Provide a succinct answer. -6.69. What is the difference between the Total Labor Force (in %) in Sub-Saharan Africa (developing only) in 2002 and the Total Labor Force (in %) in Gabon in 2003?
Offer a very short reply. 11.97. What is the difference between the Total Labor Force (in %) of Sub-Saharan Africa (developing only) in 2002 and the Total Labor Force (in %) of Hong Kong in 2003?
Provide a short and direct response. 4.77. What is the difference between the Total Labor Force (in %) in Gabon in 2002 and the Total Labor Force (in %) in Hong Kong in 2003?
Your answer should be very brief. -6.8. What is the difference between the Total Labor Force (in %) of European Union in 2002 and the Total Labor Force (in %) of Sub-Saharan Africa (developing only) in 2004?
Ensure brevity in your answer.  -10.71. What is the difference between the Total Labor Force (in %) of European Union in 2002 and the Total Labor Force (in %) of Gabon in 2004?
Offer a very short reply. 0.91. What is the difference between the Total Labor Force (in %) in European Union in 2002 and the Total Labor Force (in %) in Hong Kong in 2004?
Give a very brief answer. -6.49. What is the difference between the Total Labor Force (in %) of Sub-Saharan Africa (developing only) in 2002 and the Total Labor Force (in %) of Gabon in 2004?
Your answer should be compact. 12.37. What is the difference between the Total Labor Force (in %) of Sub-Saharan Africa (developing only) in 2002 and the Total Labor Force (in %) of Hong Kong in 2004?
Offer a terse response. 4.97. What is the difference between the Total Labor Force (in %) in Gabon in 2002 and the Total Labor Force (in %) in Hong Kong in 2004?
Keep it short and to the point. -6.6. What is the difference between the Total Labor Force (in %) in European Union in 2003 and the Total Labor Force (in %) in Sub-Saharan Africa (developing only) in 2004?
Ensure brevity in your answer.  -10.81. What is the difference between the Total Labor Force (in %) of European Union in 2003 and the Total Labor Force (in %) of Gabon in 2004?
Your answer should be very brief. 0.82. What is the difference between the Total Labor Force (in %) of European Union in 2003 and the Total Labor Force (in %) of Hong Kong in 2004?
Offer a terse response. -6.58. What is the difference between the Total Labor Force (in %) of Sub-Saharan Africa (developing only) in 2003 and the Total Labor Force (in %) of Gabon in 2004?
Make the answer very short. 12.02. What is the difference between the Total Labor Force (in %) in Sub-Saharan Africa (developing only) in 2003 and the Total Labor Force (in %) in Hong Kong in 2004?
Offer a very short reply. 4.62. What is the average Total Labor Force (in %) of European Union per year?
Your response must be concise. 65.84. What is the average Total Labor Force (in %) of Sub-Saharan Africa (developing only) per year?
Provide a short and direct response. 77.04. What is the average Total Labor Force (in %) of Gabon per year?
Keep it short and to the point. 65.86. What is the average Total Labor Force (in %) of Hong Kong per year?
Your answer should be compact. 73.22. In the year 1997, what is the difference between the Total Labor Force (in %) in European Union and Total Labor Force (in %) in Sub-Saharan Africa (developing only)?
Provide a short and direct response. -11.37. In the year 1997, what is the difference between the Total Labor Force (in %) in European Union and Total Labor Force (in %) in Gabon?
Your answer should be very brief. -0.84. In the year 1997, what is the difference between the Total Labor Force (in %) of European Union and Total Labor Force (in %) of Hong Kong?
Your response must be concise. -8.74. In the year 1997, what is the difference between the Total Labor Force (in %) in Sub-Saharan Africa (developing only) and Total Labor Force (in %) in Gabon?
Ensure brevity in your answer.  10.52. In the year 1997, what is the difference between the Total Labor Force (in %) in Sub-Saharan Africa (developing only) and Total Labor Force (in %) in Hong Kong?
Make the answer very short. 2.62. In the year 1997, what is the difference between the Total Labor Force (in %) in Gabon and Total Labor Force (in %) in Hong Kong?
Your answer should be very brief. -7.9. In the year 1998, what is the difference between the Total Labor Force (in %) in European Union and Total Labor Force (in %) in Sub-Saharan Africa (developing only)?
Give a very brief answer. -11.21. In the year 1998, what is the difference between the Total Labor Force (in %) in European Union and Total Labor Force (in %) in Gabon?
Provide a short and direct response. -0.46. In the year 1998, what is the difference between the Total Labor Force (in %) in European Union and Total Labor Force (in %) in Hong Kong?
Offer a terse response. -8.26. In the year 1998, what is the difference between the Total Labor Force (in %) in Sub-Saharan Africa (developing only) and Total Labor Force (in %) in Gabon?
Ensure brevity in your answer.  10.75. In the year 1998, what is the difference between the Total Labor Force (in %) in Sub-Saharan Africa (developing only) and Total Labor Force (in %) in Hong Kong?
Make the answer very short. 2.95. In the year 1998, what is the difference between the Total Labor Force (in %) of Gabon and Total Labor Force (in %) of Hong Kong?
Give a very brief answer. -7.8. In the year 1999, what is the difference between the Total Labor Force (in %) in European Union and Total Labor Force (in %) in Sub-Saharan Africa (developing only)?
Your answer should be compact. -11.24. In the year 1999, what is the difference between the Total Labor Force (in %) in European Union and Total Labor Force (in %) in Gabon?
Offer a very short reply. -0.34. In the year 1999, what is the difference between the Total Labor Force (in %) in European Union and Total Labor Force (in %) in Hong Kong?
Give a very brief answer. -7.74. In the year 1999, what is the difference between the Total Labor Force (in %) of Sub-Saharan Africa (developing only) and Total Labor Force (in %) of Gabon?
Your answer should be compact. 10.9. In the year 1999, what is the difference between the Total Labor Force (in %) in Sub-Saharan Africa (developing only) and Total Labor Force (in %) in Hong Kong?
Keep it short and to the point. 3.5. In the year 1999, what is the difference between the Total Labor Force (in %) of Gabon and Total Labor Force (in %) of Hong Kong?
Offer a terse response. -7.4. In the year 2000, what is the difference between the Total Labor Force (in %) in European Union and Total Labor Force (in %) in Sub-Saharan Africa (developing only)?
Your response must be concise. -11.15. In the year 2000, what is the difference between the Total Labor Force (in %) of European Union and Total Labor Force (in %) of Gabon?
Provide a succinct answer. -0.04. In the year 2000, what is the difference between the Total Labor Force (in %) in European Union and Total Labor Force (in %) in Hong Kong?
Your answer should be very brief. -7.24. In the year 2000, what is the difference between the Total Labor Force (in %) of Sub-Saharan Africa (developing only) and Total Labor Force (in %) of Gabon?
Your answer should be compact. 11.11. In the year 2000, what is the difference between the Total Labor Force (in %) in Sub-Saharan Africa (developing only) and Total Labor Force (in %) in Hong Kong?
Offer a very short reply. 3.91. In the year 2001, what is the difference between the Total Labor Force (in %) of European Union and Total Labor Force (in %) of Sub-Saharan Africa (developing only)?
Your answer should be compact. -11.3. In the year 2001, what is the difference between the Total Labor Force (in %) of European Union and Total Labor Force (in %) of Gabon?
Make the answer very short. 0.06. In the year 2001, what is the difference between the Total Labor Force (in %) of European Union and Total Labor Force (in %) of Hong Kong?
Offer a terse response. -6.94. In the year 2001, what is the difference between the Total Labor Force (in %) of Sub-Saharan Africa (developing only) and Total Labor Force (in %) of Gabon?
Provide a succinct answer. 11.36. In the year 2001, what is the difference between the Total Labor Force (in %) of Sub-Saharan Africa (developing only) and Total Labor Force (in %) of Hong Kong?
Provide a short and direct response. 4.36. In the year 2001, what is the difference between the Total Labor Force (in %) in Gabon and Total Labor Force (in %) in Hong Kong?
Provide a short and direct response. -7. In the year 2002, what is the difference between the Total Labor Force (in %) of European Union and Total Labor Force (in %) of Sub-Saharan Africa (developing only)?
Provide a succinct answer. -11.46. In the year 2002, what is the difference between the Total Labor Force (in %) of European Union and Total Labor Force (in %) of Gabon?
Give a very brief answer. 0.11. In the year 2002, what is the difference between the Total Labor Force (in %) of European Union and Total Labor Force (in %) of Hong Kong?
Your answer should be very brief. -6.89. In the year 2002, what is the difference between the Total Labor Force (in %) of Sub-Saharan Africa (developing only) and Total Labor Force (in %) of Gabon?
Offer a very short reply. 11.57. In the year 2002, what is the difference between the Total Labor Force (in %) of Sub-Saharan Africa (developing only) and Total Labor Force (in %) of Hong Kong?
Give a very brief answer. 4.57. In the year 2003, what is the difference between the Total Labor Force (in %) in European Union and Total Labor Force (in %) in Sub-Saharan Africa (developing only)?
Your answer should be compact. -11.2. In the year 2003, what is the difference between the Total Labor Force (in %) of European Union and Total Labor Force (in %) of Gabon?
Your response must be concise. 0.42. In the year 2003, what is the difference between the Total Labor Force (in %) in European Union and Total Labor Force (in %) in Hong Kong?
Ensure brevity in your answer.  -6.78. In the year 2003, what is the difference between the Total Labor Force (in %) in Sub-Saharan Africa (developing only) and Total Labor Force (in %) in Gabon?
Your answer should be compact. 11.62. In the year 2003, what is the difference between the Total Labor Force (in %) of Sub-Saharan Africa (developing only) and Total Labor Force (in %) of Hong Kong?
Ensure brevity in your answer.  4.42. In the year 2003, what is the difference between the Total Labor Force (in %) of Gabon and Total Labor Force (in %) of Hong Kong?
Your response must be concise. -7.2. In the year 2004, what is the difference between the Total Labor Force (in %) in European Union and Total Labor Force (in %) in Sub-Saharan Africa (developing only)?
Give a very brief answer. -10.75. In the year 2004, what is the difference between the Total Labor Force (in %) in European Union and Total Labor Force (in %) in Gabon?
Your response must be concise. 0.87. In the year 2004, what is the difference between the Total Labor Force (in %) of European Union and Total Labor Force (in %) of Hong Kong?
Offer a terse response. -6.53. In the year 2004, what is the difference between the Total Labor Force (in %) in Sub-Saharan Africa (developing only) and Total Labor Force (in %) in Gabon?
Your response must be concise. 11.62. In the year 2004, what is the difference between the Total Labor Force (in %) of Sub-Saharan Africa (developing only) and Total Labor Force (in %) of Hong Kong?
Make the answer very short. 4.22. In the year 2004, what is the difference between the Total Labor Force (in %) of Gabon and Total Labor Force (in %) of Hong Kong?
Your answer should be compact. -7.4. What is the ratio of the Total Labor Force (in %) of Sub-Saharan Africa (developing only) in 1997 to that in 1998?
Give a very brief answer. 1. What is the ratio of the Total Labor Force (in %) of Gabon in 1997 to that in 1998?
Ensure brevity in your answer.  1.01. What is the ratio of the Total Labor Force (in %) in Hong Kong in 1997 to that in 1998?
Give a very brief answer. 1.01. What is the ratio of the Total Labor Force (in %) of European Union in 1997 to that in 1999?
Keep it short and to the point. 1.01. What is the ratio of the Total Labor Force (in %) in Sub-Saharan Africa (developing only) in 1997 to that in 1999?
Keep it short and to the point. 1.01. What is the ratio of the Total Labor Force (in %) in Gabon in 1997 to that in 1999?
Make the answer very short. 1.01. What is the ratio of the Total Labor Force (in %) of Hong Kong in 1997 to that in 1999?
Make the answer very short. 1.02. What is the ratio of the Total Labor Force (in %) of European Union in 1997 to that in 2000?
Provide a short and direct response. 1.01. What is the ratio of the Total Labor Force (in %) of Sub-Saharan Africa (developing only) in 1997 to that in 2000?
Ensure brevity in your answer.  1.01. What is the ratio of the Total Labor Force (in %) in Gabon in 1997 to that in 2000?
Your answer should be very brief. 1.02. What is the ratio of the Total Labor Force (in %) of Hong Kong in 1997 to that in 2000?
Your response must be concise. 1.03. What is the ratio of the Total Labor Force (in %) of European Union in 1997 to that in 2001?
Provide a short and direct response. 1.01. What is the ratio of the Total Labor Force (in %) of Sub-Saharan Africa (developing only) in 1997 to that in 2001?
Ensure brevity in your answer.  1.01. What is the ratio of the Total Labor Force (in %) of Gabon in 1997 to that in 2001?
Offer a terse response. 1.03. What is the ratio of the Total Labor Force (in %) in Hong Kong in 1997 to that in 2001?
Make the answer very short. 1.04. What is the ratio of the Total Labor Force (in %) in European Union in 1997 to that in 2002?
Ensure brevity in your answer.  1.02. What is the ratio of the Total Labor Force (in %) in Sub-Saharan Africa (developing only) in 1997 to that in 2002?
Offer a very short reply. 1.01. What is the ratio of the Total Labor Force (in %) of Gabon in 1997 to that in 2002?
Your answer should be compact. 1.03. What is the ratio of the Total Labor Force (in %) in Hong Kong in 1997 to that in 2002?
Offer a very short reply. 1.04. What is the ratio of the Total Labor Force (in %) in European Union in 1997 to that in 2003?
Provide a succinct answer. 1.02. What is the ratio of the Total Labor Force (in %) in Sub-Saharan Africa (developing only) in 1997 to that in 2003?
Give a very brief answer. 1.02. What is the ratio of the Total Labor Force (in %) in Gabon in 1997 to that in 2003?
Make the answer very short. 1.04. What is the ratio of the Total Labor Force (in %) of Hong Kong in 1997 to that in 2003?
Keep it short and to the point. 1.05. What is the ratio of the Total Labor Force (in %) in European Union in 1997 to that in 2004?
Make the answer very short. 1.02. What is the ratio of the Total Labor Force (in %) in Gabon in 1997 to that in 2004?
Make the answer very short. 1.05. What is the ratio of the Total Labor Force (in %) in Hong Kong in 1997 to that in 2004?
Offer a terse response. 1.05. What is the ratio of the Total Labor Force (in %) of European Union in 1998 to that in 1999?
Offer a terse response. 1. What is the ratio of the Total Labor Force (in %) of Sub-Saharan Africa (developing only) in 1998 to that in 1999?
Give a very brief answer. 1. What is the ratio of the Total Labor Force (in %) in Gabon in 1998 to that in 1999?
Ensure brevity in your answer.  1.01. What is the ratio of the Total Labor Force (in %) of Hong Kong in 1998 to that in 1999?
Give a very brief answer. 1.01. What is the ratio of the Total Labor Force (in %) in Sub-Saharan Africa (developing only) in 1998 to that in 2000?
Offer a very short reply. 1.01. What is the ratio of the Total Labor Force (in %) of Gabon in 1998 to that in 2000?
Make the answer very short. 1.01. What is the ratio of the Total Labor Force (in %) in Hong Kong in 1998 to that in 2000?
Your answer should be compact. 1.02. What is the ratio of the Total Labor Force (in %) of Sub-Saharan Africa (developing only) in 1998 to that in 2001?
Ensure brevity in your answer.  1.01. What is the ratio of the Total Labor Force (in %) of Gabon in 1998 to that in 2001?
Provide a short and direct response. 1.02. What is the ratio of the Total Labor Force (in %) of Hong Kong in 1998 to that in 2001?
Provide a succinct answer. 1.03. What is the ratio of the Total Labor Force (in %) of European Union in 1998 to that in 2002?
Provide a short and direct response. 1.02. What is the ratio of the Total Labor Force (in %) in Sub-Saharan Africa (developing only) in 1998 to that in 2002?
Your answer should be very brief. 1.01. What is the ratio of the Total Labor Force (in %) of Gabon in 1998 to that in 2002?
Offer a terse response. 1.03. What is the ratio of the Total Labor Force (in %) of Hong Kong in 1998 to that in 2002?
Your answer should be very brief. 1.03. What is the ratio of the Total Labor Force (in %) of European Union in 1998 to that in 2003?
Your answer should be compact. 1.02. What is the ratio of the Total Labor Force (in %) of Sub-Saharan Africa (developing only) in 1998 to that in 2003?
Keep it short and to the point. 1.02. What is the ratio of the Total Labor Force (in %) in Gabon in 1998 to that in 2003?
Your response must be concise. 1.03. What is the ratio of the Total Labor Force (in %) in Hong Kong in 1998 to that in 2003?
Your response must be concise. 1.04. What is the ratio of the Total Labor Force (in %) in European Union in 1998 to that in 2004?
Keep it short and to the point. 1.02. What is the ratio of the Total Labor Force (in %) of Sub-Saharan Africa (developing only) in 1998 to that in 2004?
Keep it short and to the point. 1.02. What is the ratio of the Total Labor Force (in %) in Gabon in 1998 to that in 2004?
Give a very brief answer. 1.04. What is the ratio of the Total Labor Force (in %) in Hong Kong in 1998 to that in 2004?
Offer a terse response. 1.04. What is the ratio of the Total Labor Force (in %) in Hong Kong in 1999 to that in 2000?
Ensure brevity in your answer.  1.01. What is the ratio of the Total Labor Force (in %) in Gabon in 1999 to that in 2001?
Keep it short and to the point. 1.01. What is the ratio of the Total Labor Force (in %) of Hong Kong in 1999 to that in 2001?
Your answer should be very brief. 1.02. What is the ratio of the Total Labor Force (in %) of Sub-Saharan Africa (developing only) in 1999 to that in 2002?
Offer a terse response. 1.01. What is the ratio of the Total Labor Force (in %) of Gabon in 1999 to that in 2002?
Provide a succinct answer. 1.02. What is the ratio of the Total Labor Force (in %) of Hong Kong in 1999 to that in 2002?
Provide a short and direct response. 1.02. What is the ratio of the Total Labor Force (in %) in European Union in 1999 to that in 2003?
Provide a short and direct response. 1.01. What is the ratio of the Total Labor Force (in %) of Sub-Saharan Africa (developing only) in 1999 to that in 2003?
Provide a short and direct response. 1.01. What is the ratio of the Total Labor Force (in %) of Gabon in 1999 to that in 2003?
Offer a terse response. 1.03. What is the ratio of the Total Labor Force (in %) of Hong Kong in 1999 to that in 2003?
Provide a short and direct response. 1.03. What is the ratio of the Total Labor Force (in %) of European Union in 1999 to that in 2004?
Offer a very short reply. 1.01. What is the ratio of the Total Labor Force (in %) in Sub-Saharan Africa (developing only) in 1999 to that in 2004?
Your response must be concise. 1.02. What is the ratio of the Total Labor Force (in %) in Gabon in 1999 to that in 2004?
Offer a terse response. 1.03. What is the ratio of the Total Labor Force (in %) of Hong Kong in 1999 to that in 2004?
Your answer should be compact. 1.03. What is the ratio of the Total Labor Force (in %) in Sub-Saharan Africa (developing only) in 2000 to that in 2001?
Your response must be concise. 1. What is the ratio of the Total Labor Force (in %) of Gabon in 2000 to that in 2001?
Keep it short and to the point. 1.01. What is the ratio of the Total Labor Force (in %) in Hong Kong in 2000 to that in 2001?
Offer a terse response. 1.01. What is the ratio of the Total Labor Force (in %) of European Union in 2000 to that in 2002?
Your answer should be very brief. 1.01. What is the ratio of the Total Labor Force (in %) of Gabon in 2000 to that in 2002?
Provide a short and direct response. 1.01. What is the ratio of the Total Labor Force (in %) of Hong Kong in 2000 to that in 2002?
Ensure brevity in your answer.  1.02. What is the ratio of the Total Labor Force (in %) of European Union in 2000 to that in 2003?
Give a very brief answer. 1.01. What is the ratio of the Total Labor Force (in %) of Sub-Saharan Africa (developing only) in 2000 to that in 2003?
Offer a terse response. 1.01. What is the ratio of the Total Labor Force (in %) in Gabon in 2000 to that in 2003?
Your answer should be compact. 1.02. What is the ratio of the Total Labor Force (in %) in Hong Kong in 2000 to that in 2003?
Make the answer very short. 1.02. What is the ratio of the Total Labor Force (in %) of European Union in 2000 to that in 2004?
Give a very brief answer. 1.01. What is the ratio of the Total Labor Force (in %) of Sub-Saharan Africa (developing only) in 2000 to that in 2004?
Ensure brevity in your answer.  1.02. What is the ratio of the Total Labor Force (in %) of Gabon in 2000 to that in 2004?
Offer a very short reply. 1.03. What is the ratio of the Total Labor Force (in %) in Hong Kong in 2000 to that in 2004?
Provide a succinct answer. 1.02. What is the ratio of the Total Labor Force (in %) of European Union in 2001 to that in 2002?
Keep it short and to the point. 1.01. What is the ratio of the Total Labor Force (in %) of Sub-Saharan Africa (developing only) in 2001 to that in 2002?
Offer a terse response. 1. What is the ratio of the Total Labor Force (in %) of Gabon in 2001 to that in 2002?
Your answer should be compact. 1.01. What is the ratio of the Total Labor Force (in %) in Hong Kong in 2001 to that in 2002?
Give a very brief answer. 1.01. What is the ratio of the Total Labor Force (in %) in European Union in 2001 to that in 2003?
Ensure brevity in your answer.  1.01. What is the ratio of the Total Labor Force (in %) in Sub-Saharan Africa (developing only) in 2001 to that in 2003?
Your answer should be compact. 1.01. What is the ratio of the Total Labor Force (in %) in Gabon in 2001 to that in 2003?
Make the answer very short. 1.01. What is the ratio of the Total Labor Force (in %) of Hong Kong in 2001 to that in 2003?
Make the answer very short. 1.01. What is the ratio of the Total Labor Force (in %) in European Union in 2001 to that in 2004?
Give a very brief answer. 1.01. What is the ratio of the Total Labor Force (in %) of Sub-Saharan Africa (developing only) in 2001 to that in 2004?
Offer a very short reply. 1.01. What is the ratio of the Total Labor Force (in %) of Gabon in 2001 to that in 2004?
Your response must be concise. 1.02. What is the ratio of the Total Labor Force (in %) in Hong Kong in 2001 to that in 2004?
Your answer should be compact. 1.01. What is the ratio of the Total Labor Force (in %) of Gabon in 2002 to that in 2003?
Provide a short and direct response. 1.01. What is the ratio of the Total Labor Force (in %) in Hong Kong in 2002 to that in 2003?
Keep it short and to the point. 1. What is the ratio of the Total Labor Force (in %) of Sub-Saharan Africa (developing only) in 2002 to that in 2004?
Your answer should be compact. 1.01. What is the ratio of the Total Labor Force (in %) of Gabon in 2002 to that in 2004?
Your response must be concise. 1.01. What is the ratio of the Total Labor Force (in %) of Hong Kong in 2002 to that in 2004?
Give a very brief answer. 1.01. What is the difference between the highest and the second highest Total Labor Force (in %) in European Union?
Provide a succinct answer. 0.11. What is the difference between the highest and the second highest Total Labor Force (in %) in Sub-Saharan Africa (developing only)?
Keep it short and to the point. 0.28. What is the difference between the highest and the second highest Total Labor Force (in %) of Hong Kong?
Give a very brief answer. 0.6. What is the difference between the highest and the lowest Total Labor Force (in %) in European Union?
Keep it short and to the point. 1.34. What is the difference between the highest and the lowest Total Labor Force (in %) in Sub-Saharan Africa (developing only)?
Give a very brief answer. 1.9. What is the difference between the highest and the lowest Total Labor Force (in %) of Gabon?
Make the answer very short. 3. What is the difference between the highest and the lowest Total Labor Force (in %) in Hong Kong?
Provide a succinct answer. 3.5. 